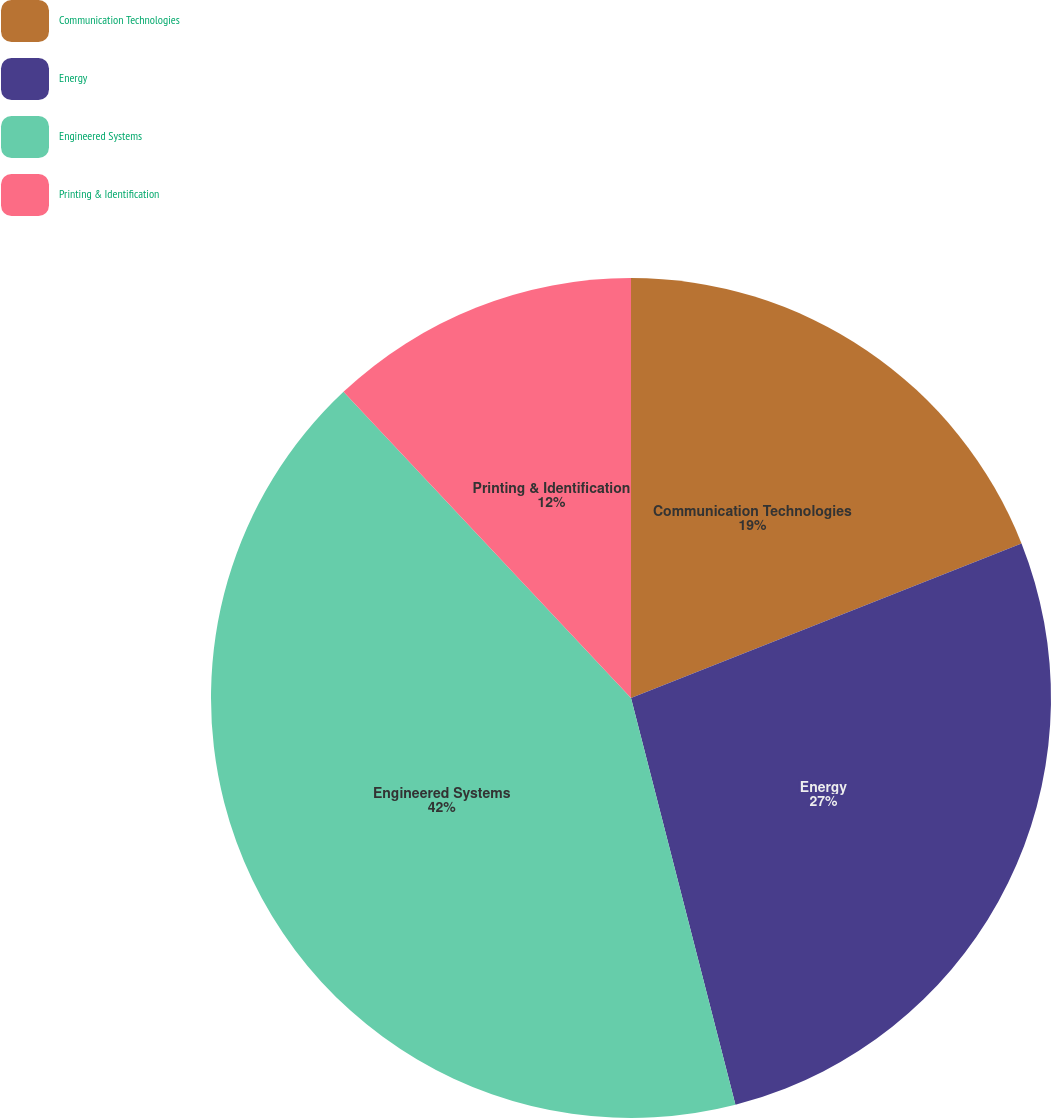Convert chart to OTSL. <chart><loc_0><loc_0><loc_500><loc_500><pie_chart><fcel>Communication Technologies<fcel>Energy<fcel>Engineered Systems<fcel>Printing & Identification<nl><fcel>19.0%<fcel>27.0%<fcel>42.0%<fcel>12.0%<nl></chart> 